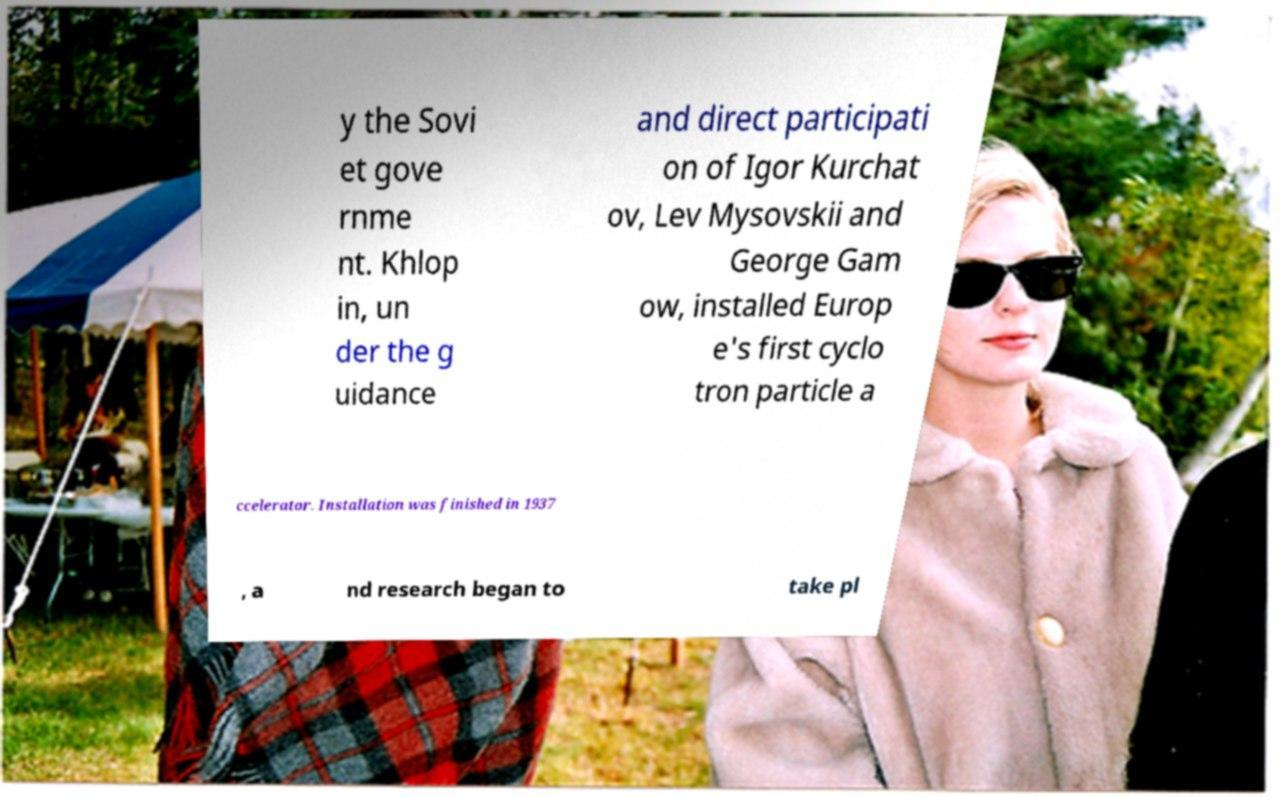Please read and relay the text visible in this image. What does it say? y the Sovi et gove rnme nt. Khlop in, un der the g uidance and direct participati on of Igor Kurchat ov, Lev Mysovskii and George Gam ow, installed Europ e's first cyclo tron particle a ccelerator. Installation was finished in 1937 , a nd research began to take pl 